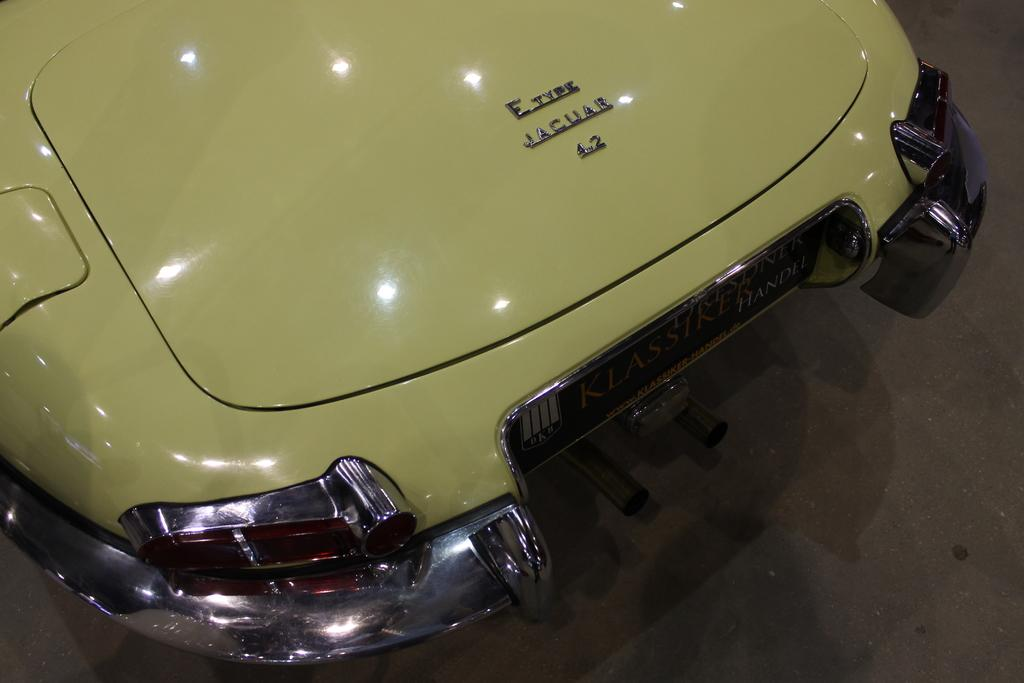What type of vehicle is in the image? There is a vehicle in the image, but the specific type is not mentioned. Which part of the vehicle is visible in the image? The front part of the vehicle is visible in the image. What is written on the vehicle? There is text written on the vehicle. What type of harmony can be heard coming from the vehicle in the image? There is no indication in the image that the vehicle is producing any sound, let alone harmony. 